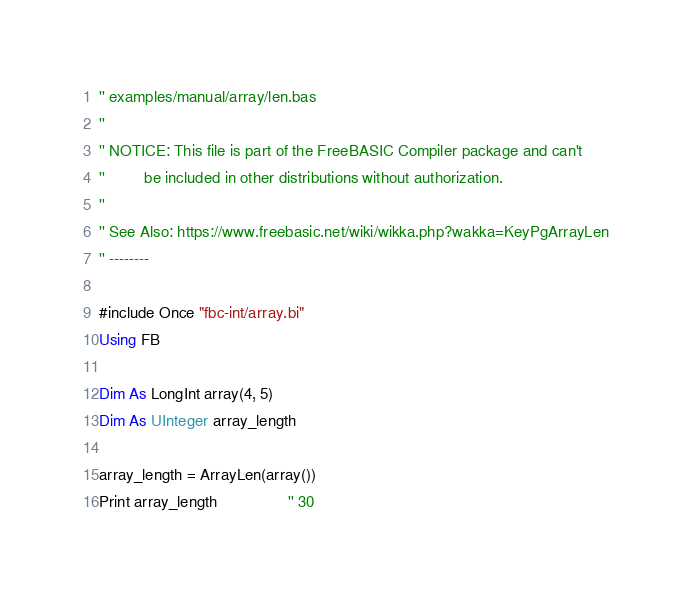<code> <loc_0><loc_0><loc_500><loc_500><_VisualBasic_>'' examples/manual/array/len.bas
''
'' NOTICE: This file is part of the FreeBASIC Compiler package and can't
''         be included in other distributions without authorization.
''
'' See Also: https://www.freebasic.net/wiki/wikka.php?wakka=KeyPgArrayLen
'' --------

#include Once "fbc-int/array.bi"
Using FB

Dim As LongInt array(4, 5)
Dim As UInteger array_length

array_length = ArrayLen(array())
Print array_length                '' 30
</code> 